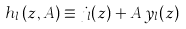Convert formula to latex. <formula><loc_0><loc_0><loc_500><loc_500>h _ { l } \left ( z , A \right ) \equiv j _ { l } ( z ) + A \, y _ { l } ( z )</formula> 